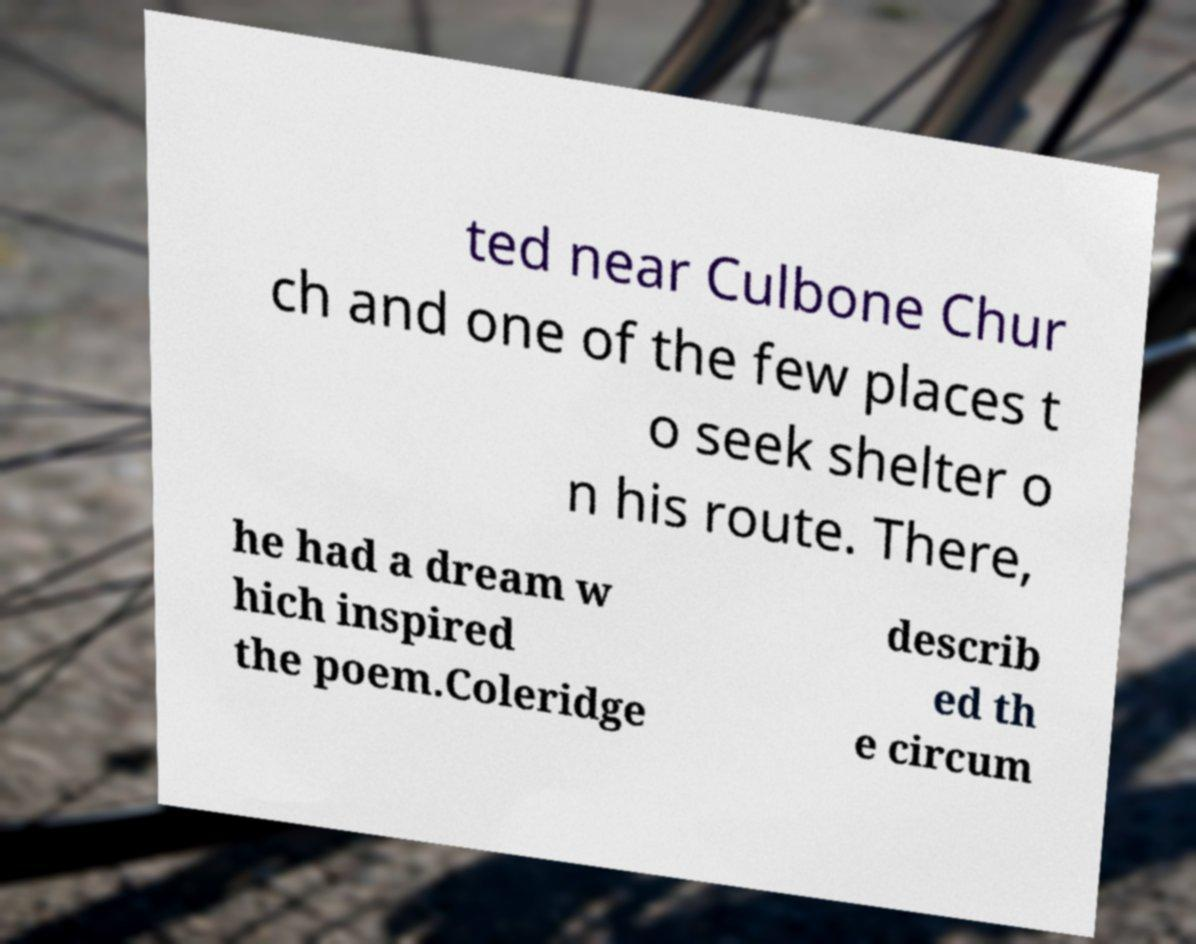Please identify and transcribe the text found in this image. ted near Culbone Chur ch and one of the few places t o seek shelter o n his route. There, he had a dream w hich inspired the poem.Coleridge describ ed th e circum 